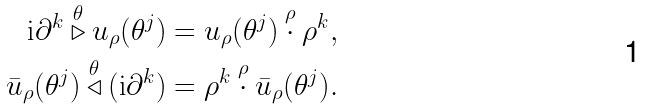Convert formula to latex. <formula><loc_0><loc_0><loc_500><loc_500>\text {i} \partial ^ { k } \overset { \theta } { \triangleright } u _ { \rho } ( \theta ^ { j } ) & = u _ { \rho } ( \theta ^ { j } ) \overset { \rho } { \cdot } \rho ^ { k } , \\ \bar { u } _ { \rho } ( \theta ^ { j } ) \overset { \theta } { \triangleleft } ( \text {i} \partial ^ { k } ) & = \rho ^ { k } \overset { \rho } { \cdot } \bar { u } _ { \rho } ( \theta ^ { j } ) .</formula> 